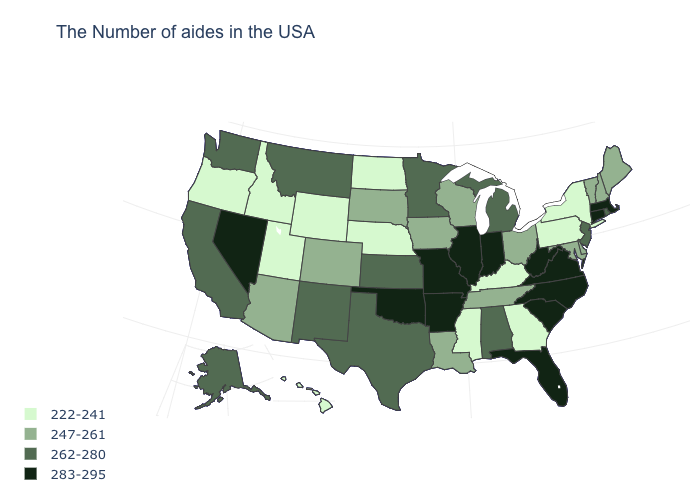Among the states that border Montana , does Wyoming have the lowest value?
Keep it brief. Yes. What is the value of New Hampshire?
Be succinct. 247-261. Name the states that have a value in the range 262-280?
Give a very brief answer. Rhode Island, New Jersey, Michigan, Alabama, Minnesota, Kansas, Texas, New Mexico, Montana, California, Washington, Alaska. Which states hav the highest value in the MidWest?
Write a very short answer. Indiana, Illinois, Missouri. Name the states that have a value in the range 247-261?
Quick response, please. Maine, New Hampshire, Vermont, Delaware, Maryland, Ohio, Tennessee, Wisconsin, Louisiana, Iowa, South Dakota, Colorado, Arizona. What is the value of Alabama?
Answer briefly. 262-280. How many symbols are there in the legend?
Quick response, please. 4. What is the lowest value in states that border Georgia?
Concise answer only. 247-261. What is the value of Missouri?
Quick response, please. 283-295. Among the states that border Texas , does Louisiana have the highest value?
Short answer required. No. Name the states that have a value in the range 283-295?
Concise answer only. Massachusetts, Connecticut, Virginia, North Carolina, South Carolina, West Virginia, Florida, Indiana, Illinois, Missouri, Arkansas, Oklahoma, Nevada. Name the states that have a value in the range 283-295?
Be succinct. Massachusetts, Connecticut, Virginia, North Carolina, South Carolina, West Virginia, Florida, Indiana, Illinois, Missouri, Arkansas, Oklahoma, Nevada. What is the value of Indiana?
Answer briefly. 283-295. What is the highest value in the MidWest ?
Answer briefly. 283-295. Does Wyoming have the same value as New York?
Keep it brief. Yes. 